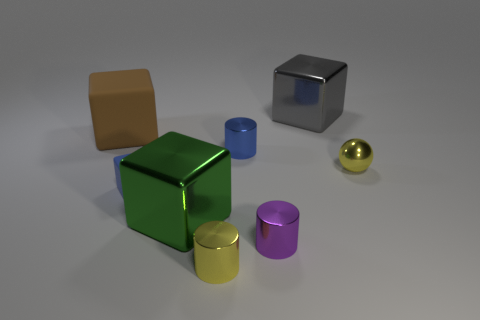Add 1 big gray metallic cubes. How many objects exist? 9 Subtract all cylinders. How many objects are left? 5 Add 8 tiny blue cylinders. How many tiny blue cylinders are left? 9 Add 5 tiny blue matte objects. How many tiny blue matte objects exist? 6 Subtract 0 yellow cubes. How many objects are left? 8 Subtract all metal cylinders. Subtract all large gray metal objects. How many objects are left? 4 